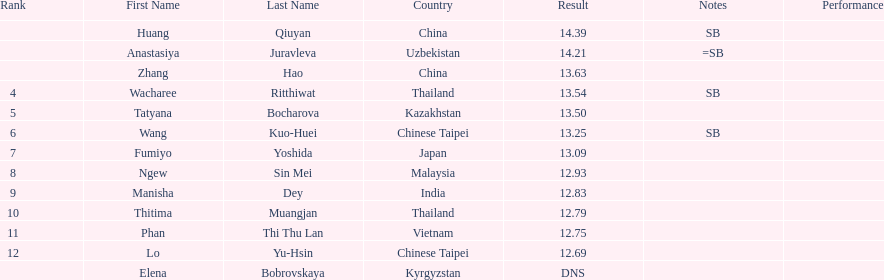How many contestants were from thailand? 2. 